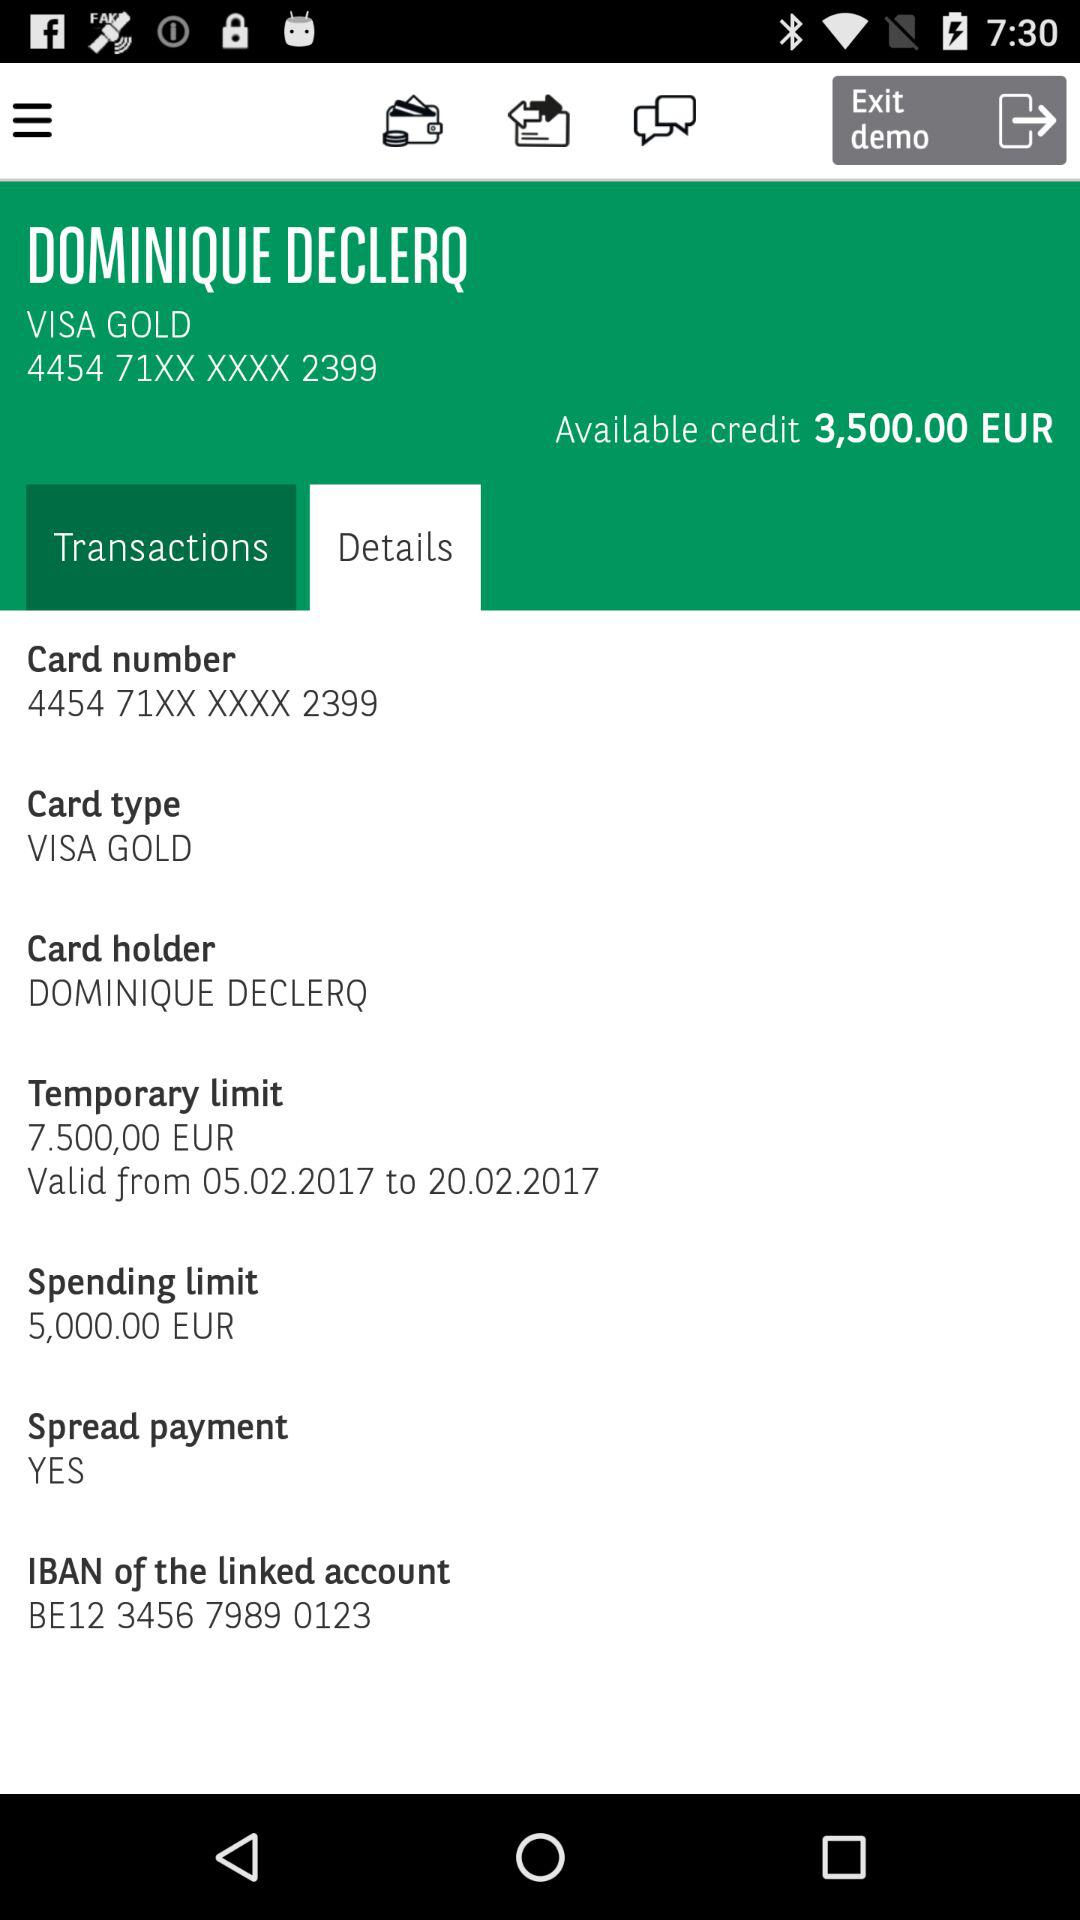How much is the spending limit?
Answer the question using a single word or phrase. 5,000.00 EUR 